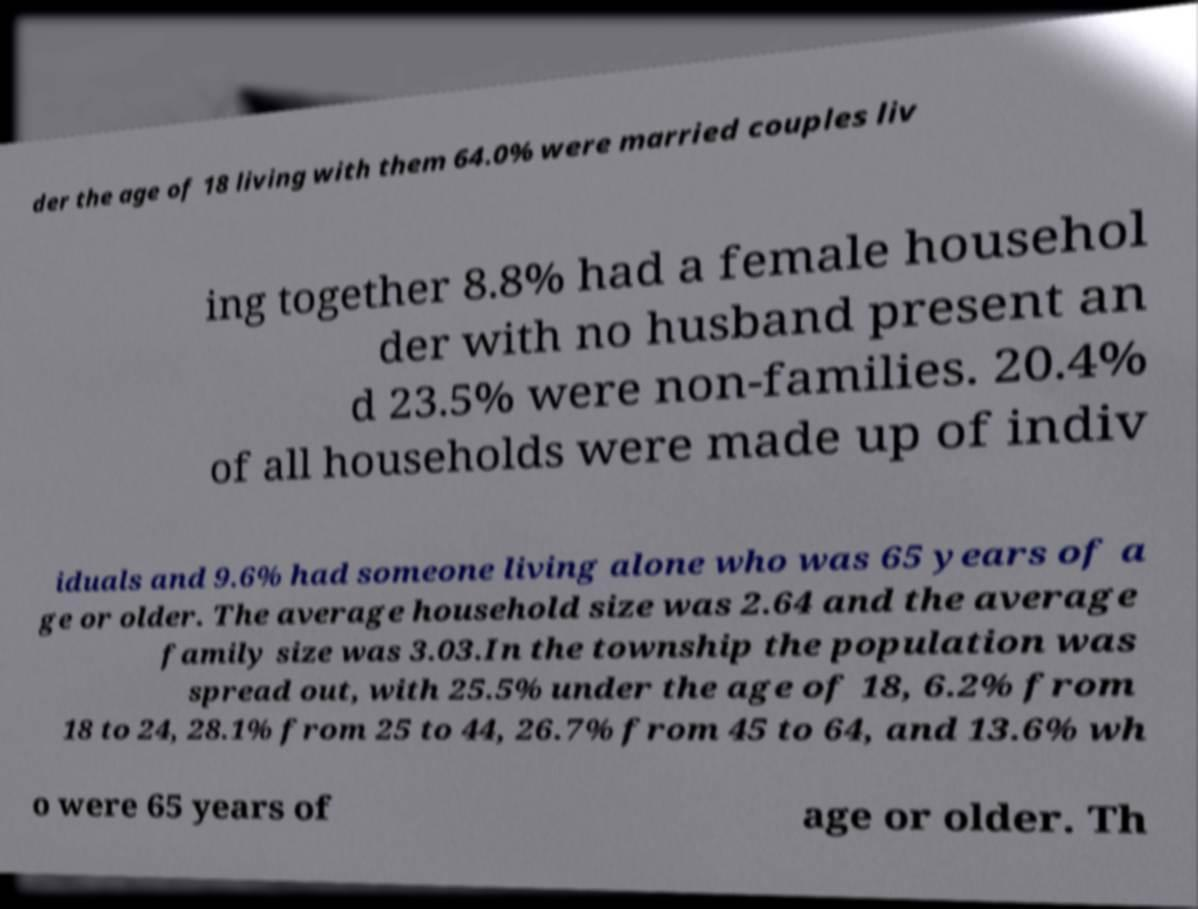There's text embedded in this image that I need extracted. Can you transcribe it verbatim? der the age of 18 living with them 64.0% were married couples liv ing together 8.8% had a female househol der with no husband present an d 23.5% were non-families. 20.4% of all households were made up of indiv iduals and 9.6% had someone living alone who was 65 years of a ge or older. The average household size was 2.64 and the average family size was 3.03.In the township the population was spread out, with 25.5% under the age of 18, 6.2% from 18 to 24, 28.1% from 25 to 44, 26.7% from 45 to 64, and 13.6% wh o were 65 years of age or older. Th 